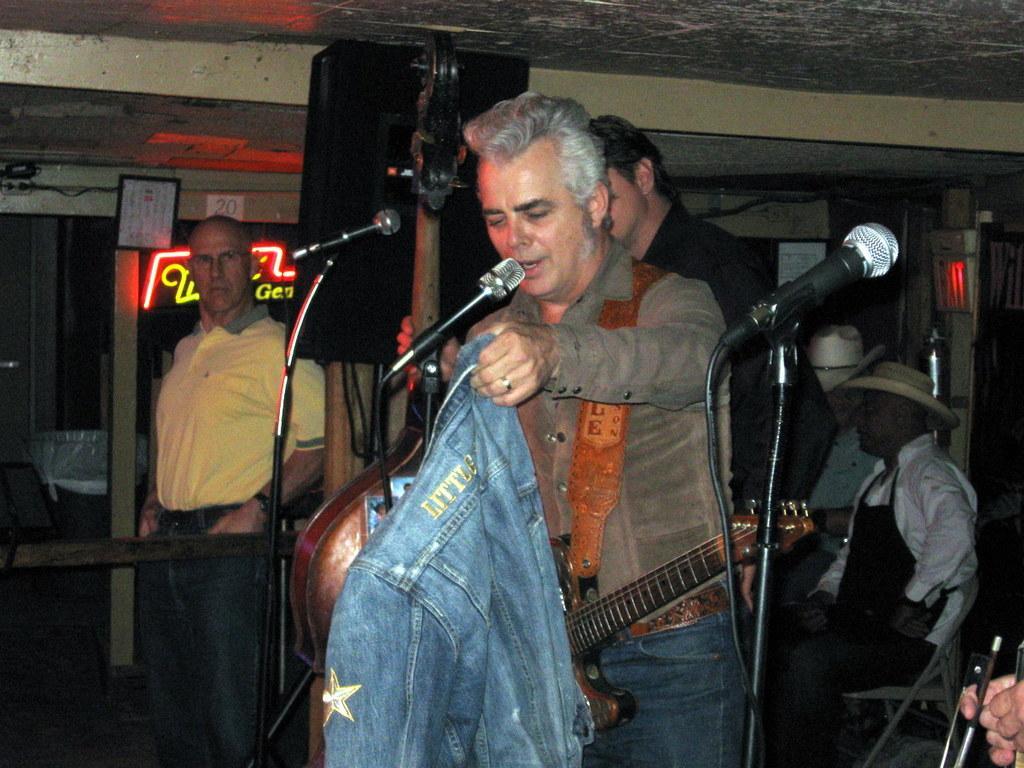How would you summarize this image in a sentence or two? In this image there is a man standing near a mike , another 2 persons standing , another 2 persons sitting in chair and the back ground there is curtain, frame , name board, speaker. 